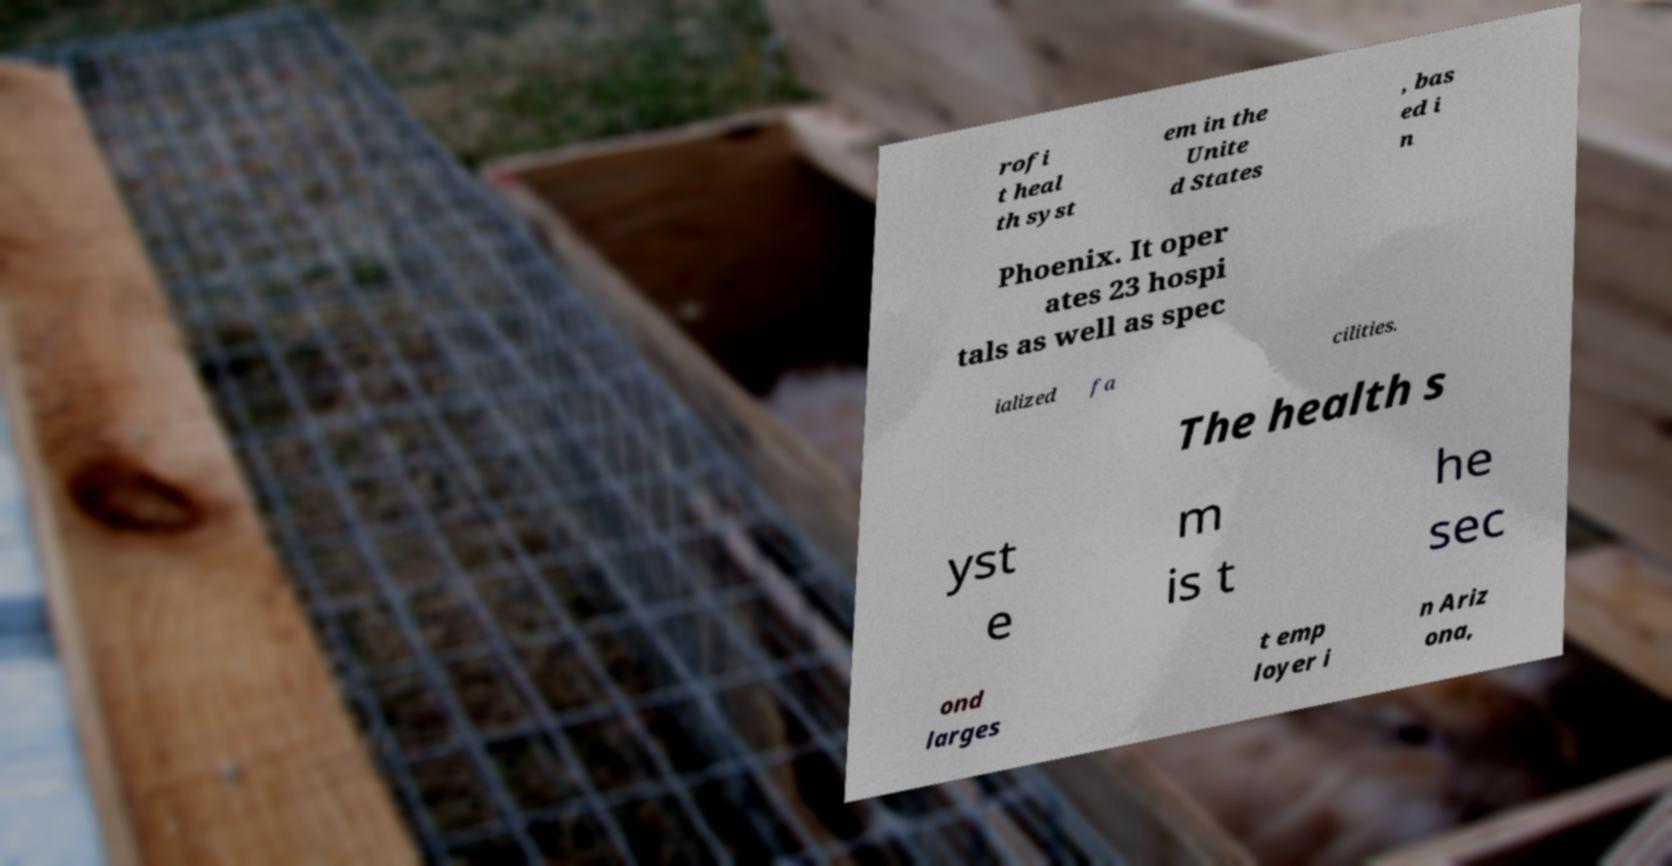Could you assist in decoding the text presented in this image and type it out clearly? rofi t heal th syst em in the Unite d States , bas ed i n Phoenix. It oper ates 23 hospi tals as well as spec ialized fa cilities. The health s yst e m is t he sec ond larges t emp loyer i n Ariz ona, 